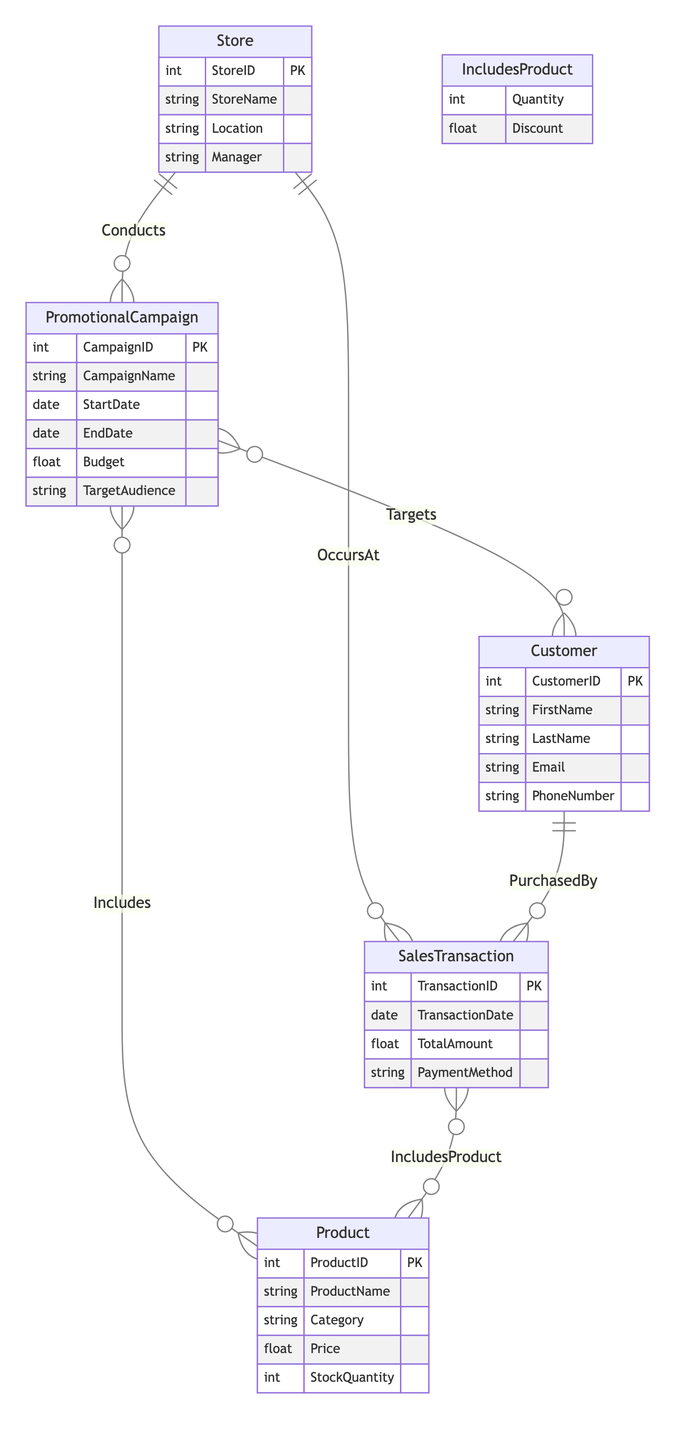What entities are involved in this diagram? The diagram includes the entities: Store, PromotionalCampaign, Product, Customer, and SalesTransaction.
Answer: Store, PromotionalCampaign, Product, Customer, SalesTransaction How many relationships are there in the diagram? There are six relationships in the diagram: Conducts, Targets, Includes, PurchasedBy, IncludesProduct, and OccursAt.
Answer: Six What is the primary key of the PromotionalCampaign entity? The primary key of the PromotionalCampaign entity is CampaignID.
Answer: CampaignID Which entity is linked to both SalesTransaction and Customer? The Customer entity is linked to the SalesTransaction through the PurchasedBy relationship.
Answer: Customer What attributes are included in the IncludesProduct relationship? The IncludesProduct relationship includes the attributes Quantity and Discount.
Answer: Quantity, Discount Which entity has a direct relationship with both Store and Product entities? The PromotionalCampaign entity has direct relationships with both Store (Conducts) and Product (Includes).
Answer: PromotionalCampaign How many attributes does the Store entity have? The Store entity has four attributes: StoreID, StoreName, Location, and Manager.
Answer: Four What is the role of the SalesTransaction entity in relation to Customer? The SalesTransaction entity plays the role of recording purchases made by Customers through the PurchasedBy relationship.
Answer: Recording purchases Which promotional campaign attribute specifies the financial plan for its implementation? The Budget attribute in the PromotionalCampaign entity specifies the financial plan.
Answer: Budget What relationship connects a SalesTransaction to the Store it occurred in? The OccursAt relationship connects a SalesTransaction to the Store it occurred in.
Answer: OccursAt 